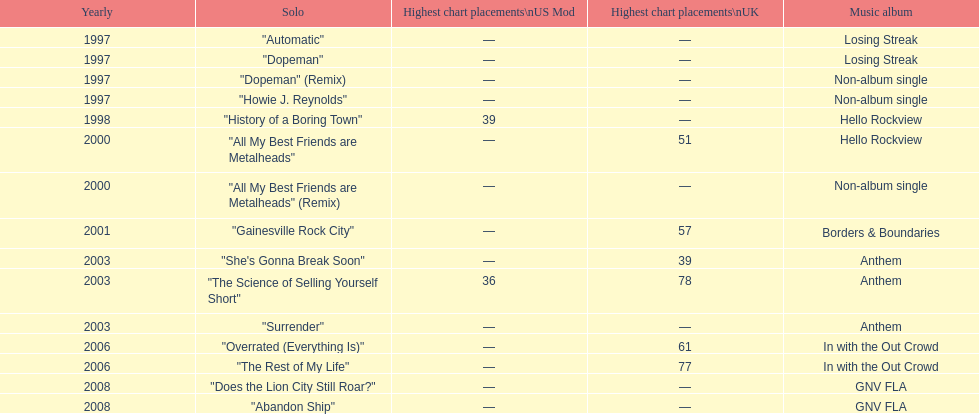What was the next single after "overrated (everything is)"? "The Rest of My Life". 